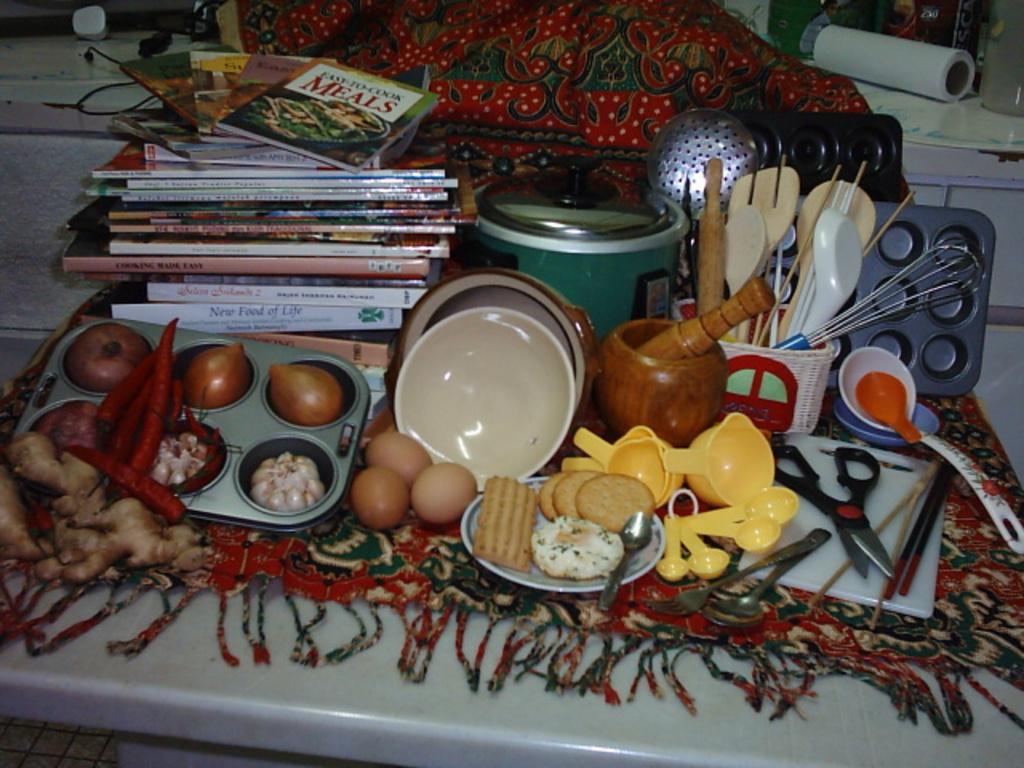What is a cookbook needed for?
Your answer should be compact. Meals. What is the title of the topmost book?
Give a very brief answer. Meals. 